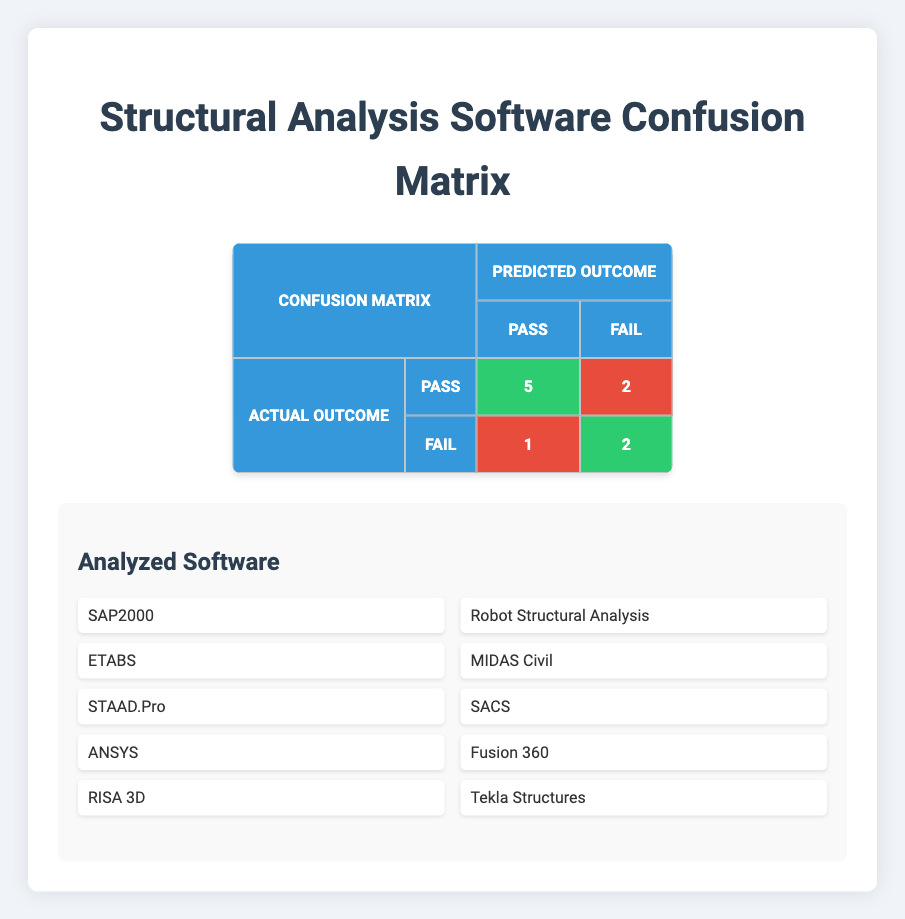What is the total number of software that passed? From the confusion matrix, we can count the number of software that achieved an actual outcome of "Pass." The software are SAP2000, ETABS, RISA 3D, MIDAS Civil, and Tekla Structures, totaling 5 software that passed.
Answer: 5 How many software had a false positive result? In the confusion matrix, a false positive is indicated by the software that had an actual outcome of "Fail" but were predicted to "Pass." According to the table, only one software, Robot Structural Analysis, fits this description, resulting in a total of 1 false positive.
Answer: 1 What is the difference between the number of true positives and false negatives? The number of true positives is 5, and the number of false negatives is 2. To find the difference, subtract the number of false negatives from the number of true positives: 5 - 2 = 3.
Answer: 3 Did any software successfully predict a fail outcome when it was actually a fail? The confusion matrix indicates software that achieved an actual outcome of "Fail" and was also predicted as "Fail." The software ANSYS and Fusion 360 both meet this criteria. Thus, the answer to the question is yes.
Answer: Yes Which software had the highest number of true positives? True positives account for cases where the expected outcome was "Pass" and the actual outcome is also "Pass." Here, SAP2000, ETABS, RISA 3D, MIDAS Civil, and Tekla Structures all had true positives, totaling 5, which is the highest.
Answer: SAP2000, ETABS, RISA 3D, MIDAS Civil, Tekla Structures What is the ratio of true negatives to false negatives? True negatives refer to the instances where the software was expected to fail and correctly failed. The number of true negatives is 2 and the number of false negatives is 2. The ratio can be calculated as 2 (true negatives) to 2 (false negatives), simplifying to 1:1.
Answer: 1:1 How many software failed when they were expected to pass? In the provided data, only STAAD.Pro and SACS had expected outcomes of "Pass" but ended with an actual outcome of "Fail." Therefore, the total number of software that failed when expected to pass is 2.
Answer: 2 Is there any software that passed but did not meet the expected outcome? A software that passed but did not meet the expected outcome would be classified as a false positive. From the confusion matrix, only Robot Structural Analysis falls under this category. Thus, there is one software that fits this description.
Answer: Yes 